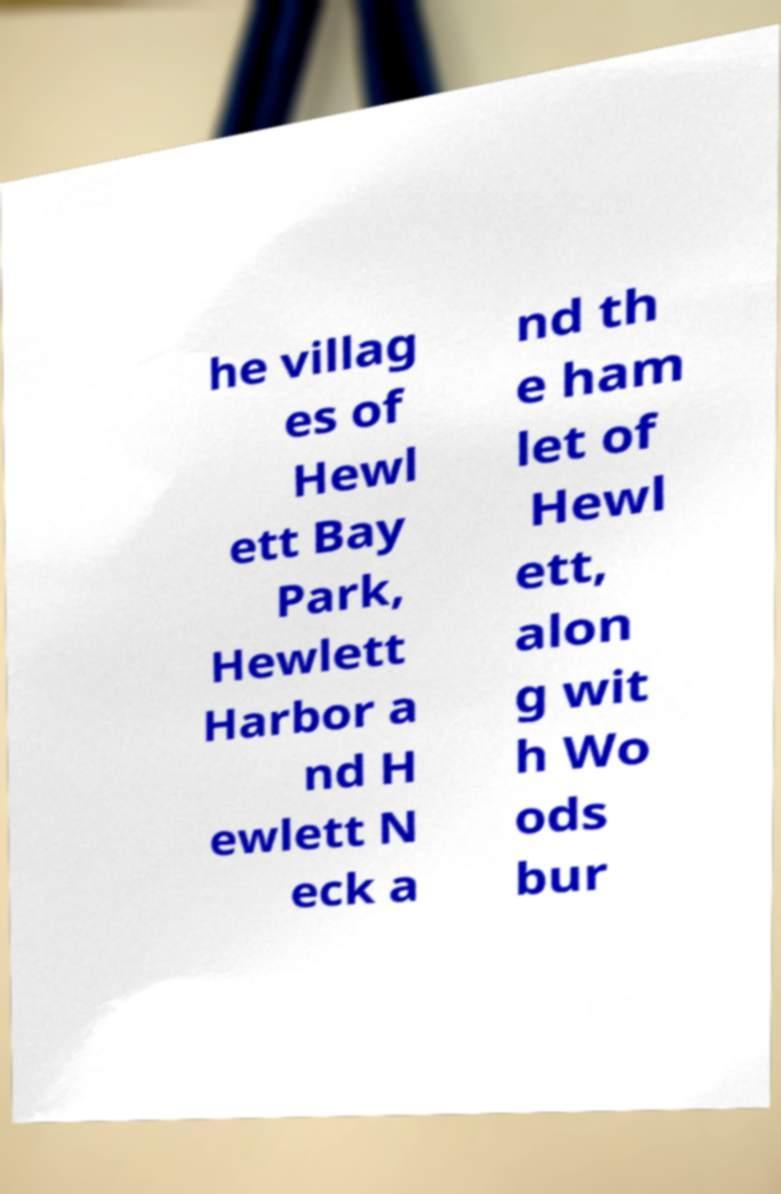Can you accurately transcribe the text from the provided image for me? he villag es of Hewl ett Bay Park, Hewlett Harbor a nd H ewlett N eck a nd th e ham let of Hewl ett, alon g wit h Wo ods bur 